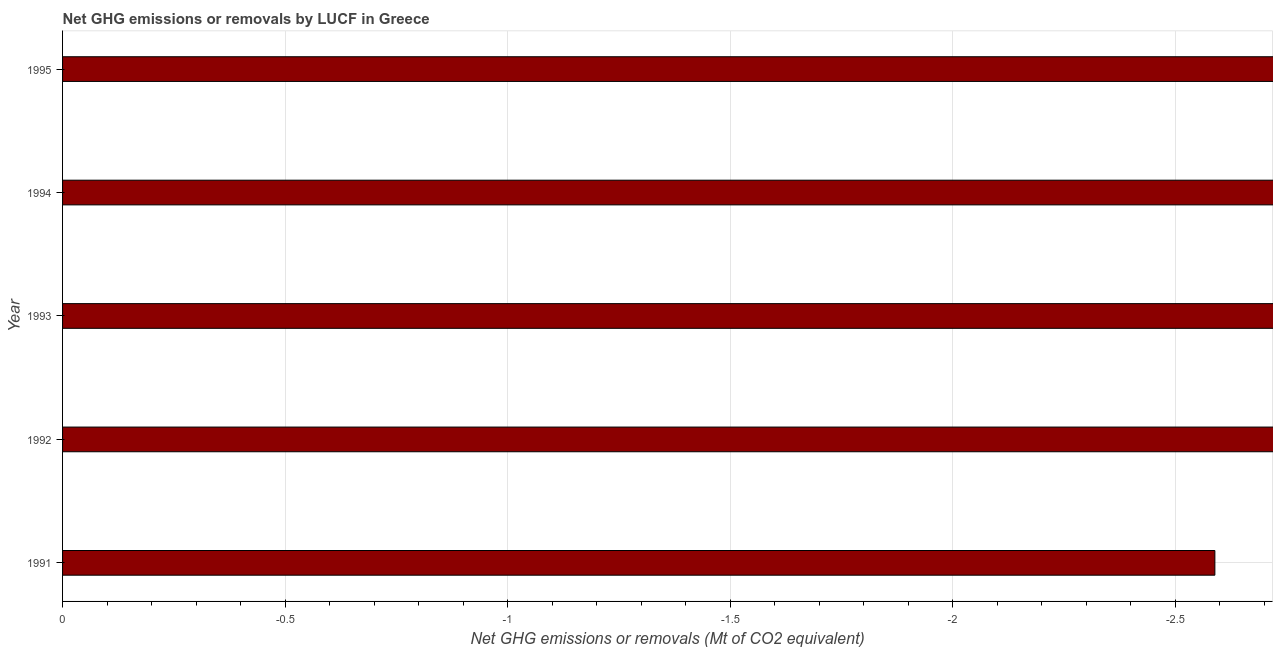Does the graph contain any zero values?
Make the answer very short. Yes. Does the graph contain grids?
Give a very brief answer. Yes. What is the title of the graph?
Keep it short and to the point. Net GHG emissions or removals by LUCF in Greece. What is the label or title of the X-axis?
Ensure brevity in your answer.  Net GHG emissions or removals (Mt of CO2 equivalent). What is the label or title of the Y-axis?
Your answer should be very brief. Year. What is the ghg net emissions or removals in 1993?
Your answer should be very brief. 0. What is the sum of the ghg net emissions or removals?
Keep it short and to the point. 0. What is the median ghg net emissions or removals?
Ensure brevity in your answer.  0. In how many years, is the ghg net emissions or removals greater than -1.5 Mt?
Keep it short and to the point. 0. What is the difference between two consecutive major ticks on the X-axis?
Ensure brevity in your answer.  0.5. Are the values on the major ticks of X-axis written in scientific E-notation?
Your answer should be very brief. No. What is the Net GHG emissions or removals (Mt of CO2 equivalent) of 1991?
Provide a succinct answer. 0. What is the Net GHG emissions or removals (Mt of CO2 equivalent) of 1994?
Provide a short and direct response. 0. 